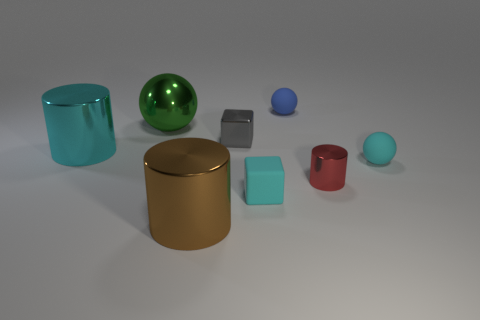What shape is the metallic thing that is left of the gray metal thing and right of the big green thing? cylinder 